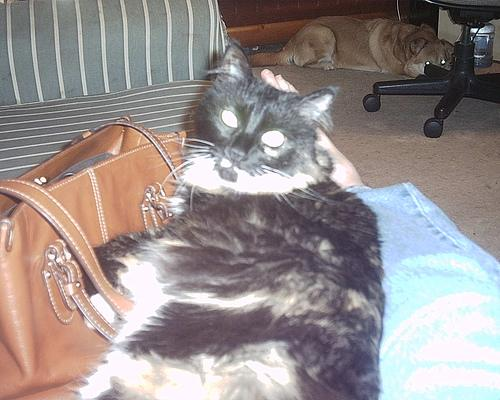Why are the animals eyes white? camera flash 